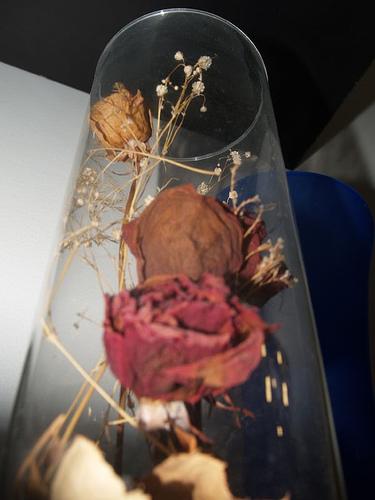What is the vase made of?
Keep it brief. Glass. Are the flowers wilted?
Keep it brief. Yes. Does the vase have a design on it?
Answer briefly. No. 